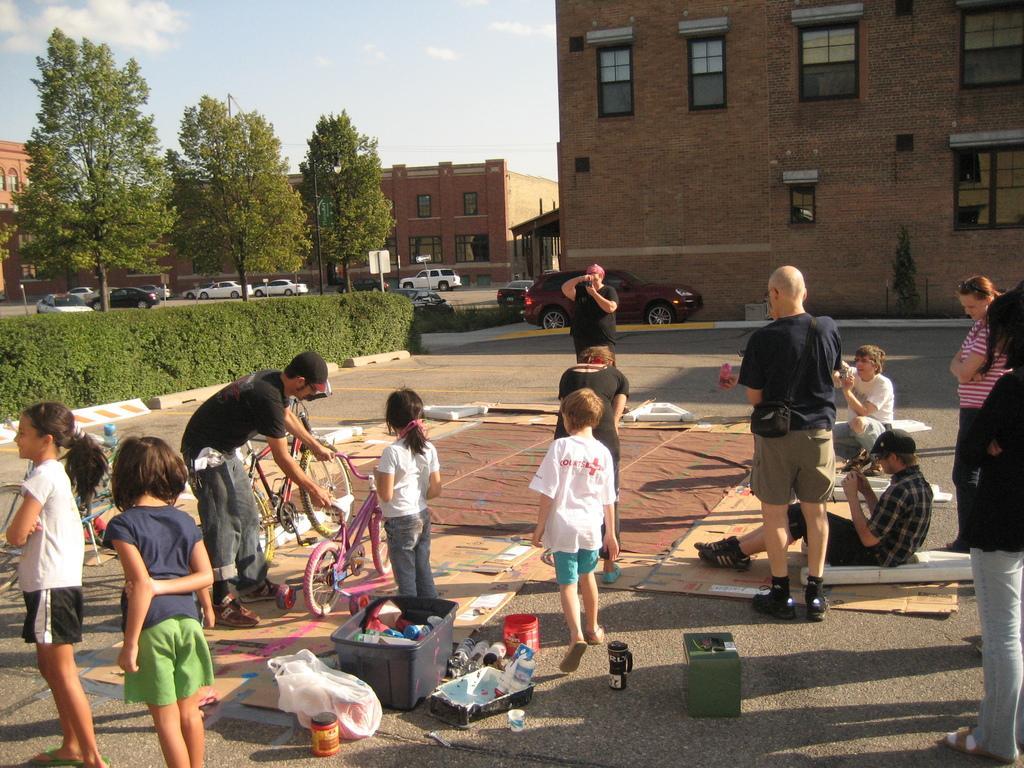Could you give a brief overview of what you see in this image? This is a place where we have a group of people sitting on the mat and around there are some cars, plants and some buildings. 